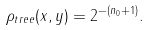Convert formula to latex. <formula><loc_0><loc_0><loc_500><loc_500>\rho _ { t r e e } ( x , y ) = 2 ^ { - ( n _ { 0 } + 1 ) } .</formula> 